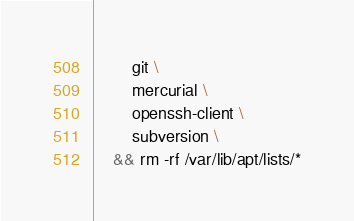Convert code to text. <code><loc_0><loc_0><loc_500><loc_500><_Dockerfile_>		git \
		mercurial \
		openssh-client \
		subversion \
	&& rm -rf /var/lib/apt/lists/*
</code> 